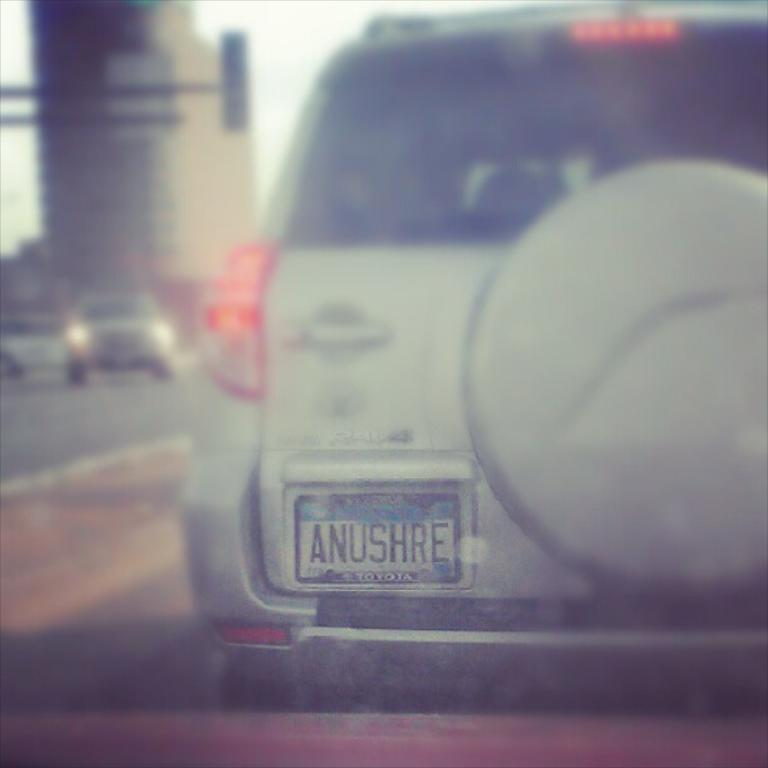<image>
Describe the image concisely. A SUV with a license plate characters ANUSHRE 